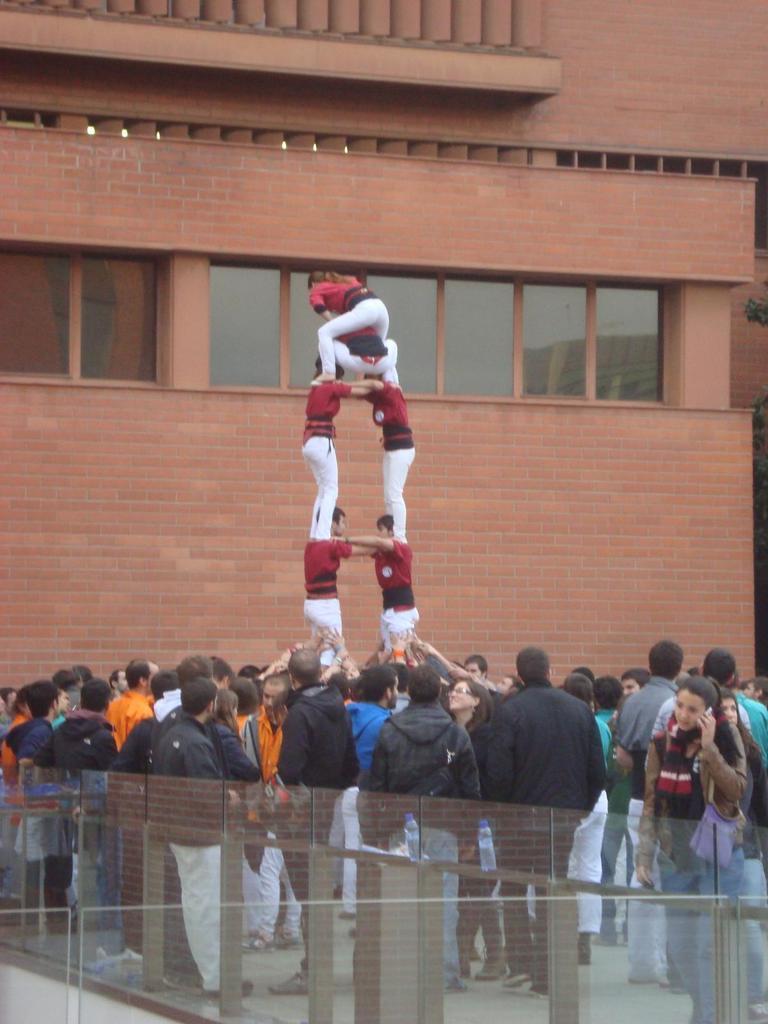In one or two sentences, can you explain what this image depicts? In this image we can see the people on the path. We can also see the glass railing. In the background we can see the building. On the right we can see a tree. 